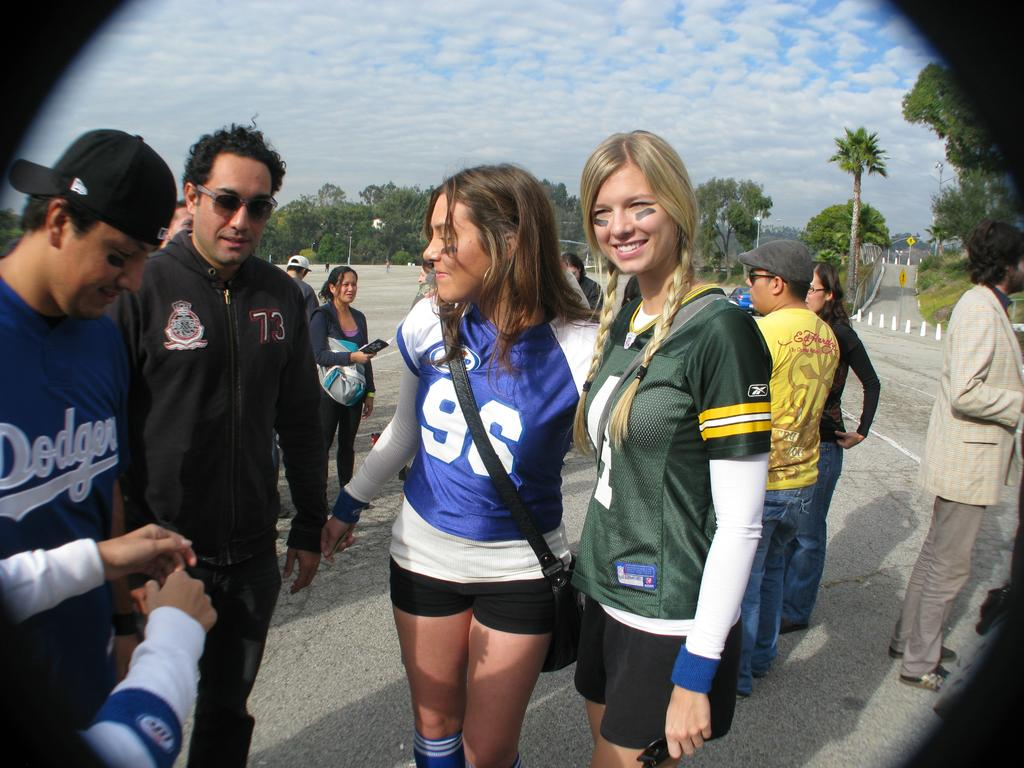<image>
Write a terse but informative summary of the picture. the number 96 is on the front of a girl's jersey 